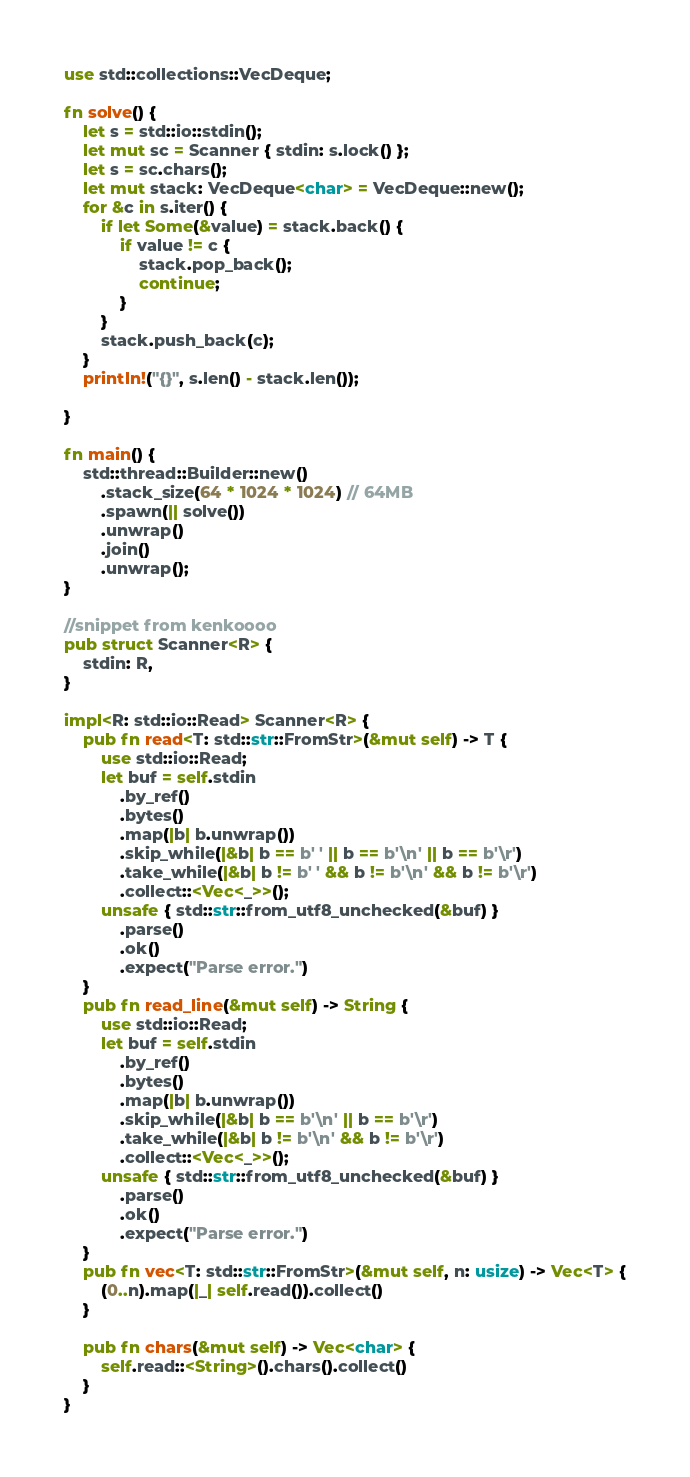Convert code to text. <code><loc_0><loc_0><loc_500><loc_500><_Rust_>use std::collections::VecDeque;

fn solve() {
    let s = std::io::stdin();
    let mut sc = Scanner { stdin: s.lock() };
    let s = sc.chars();
    let mut stack: VecDeque<char> = VecDeque::new();
    for &c in s.iter() {
        if let Some(&value) = stack.back() {
            if value != c {
                stack.pop_back();
                continue;
            }
        }
        stack.push_back(c);
    }
    println!("{}", s.len() - stack.len());
    
}

fn main() {
    std::thread::Builder::new()
        .stack_size(64 * 1024 * 1024) // 64MB
        .spawn(|| solve())
        .unwrap()
        .join()
        .unwrap();
}

//snippet from kenkoooo
pub struct Scanner<R> {
    stdin: R,
}

impl<R: std::io::Read> Scanner<R> {
    pub fn read<T: std::str::FromStr>(&mut self) -> T {
        use std::io::Read;
        let buf = self.stdin
            .by_ref()
            .bytes()
            .map(|b| b.unwrap())
            .skip_while(|&b| b == b' ' || b == b'\n' || b == b'\r')
            .take_while(|&b| b != b' ' && b != b'\n' && b != b'\r')
            .collect::<Vec<_>>();
        unsafe { std::str::from_utf8_unchecked(&buf) }
            .parse()
            .ok()
            .expect("Parse error.")
    }
    pub fn read_line(&mut self) -> String {
        use std::io::Read;
        let buf = self.stdin
            .by_ref()
            .bytes()
            .map(|b| b.unwrap())
            .skip_while(|&b| b == b'\n' || b == b'\r')
            .take_while(|&b| b != b'\n' && b != b'\r')
            .collect::<Vec<_>>();
        unsafe { std::str::from_utf8_unchecked(&buf) }
            .parse()
            .ok()
            .expect("Parse error.")
    }
    pub fn vec<T: std::str::FromStr>(&mut self, n: usize) -> Vec<T> {
        (0..n).map(|_| self.read()).collect()
    }

    pub fn chars(&mut self) -> Vec<char> {
        self.read::<String>().chars().collect()
    }
}
</code> 